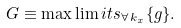<formula> <loc_0><loc_0><loc_500><loc_500>G \equiv \max \lim i t s _ { \forall \, k _ { x } } \{ g \} .</formula> 